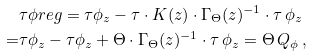Convert formula to latex. <formula><loc_0><loc_0><loc_500><loc_500>& \tau \phi r e g = \tau \phi _ { z } - \tau \cdot K ( z ) \cdot \Gamma _ { \Theta } ( z ) ^ { - 1 } \cdot \tau \, \phi _ { z } \\ = & \tau \phi _ { z } - \tau \phi _ { z } + \Theta \cdot \Gamma _ { \Theta } ( z ) ^ { - 1 } \cdot \tau \, \phi _ { z } = \Theta \, Q _ { \phi } \, ,</formula> 